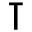<formula> <loc_0><loc_0><loc_500><loc_500>\intercal</formula> 